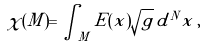<formula> <loc_0><loc_0><loc_500><loc_500>\chi ( M ) = \int _ { M } E ( x ) \sqrt { g } \, d ^ { N } x \, ,</formula> 